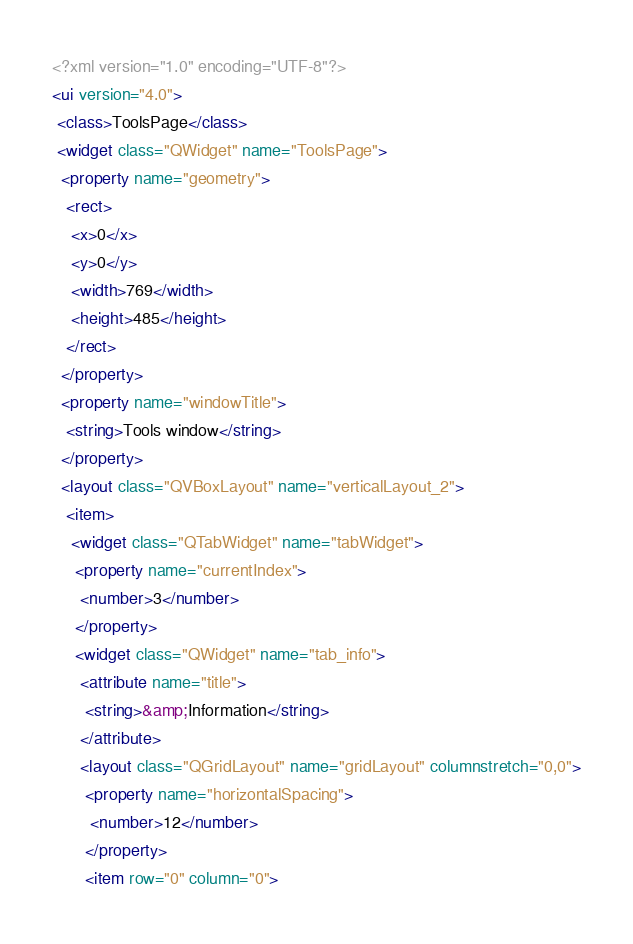<code> <loc_0><loc_0><loc_500><loc_500><_XML_><?xml version="1.0" encoding="UTF-8"?>
<ui version="4.0">
 <class>ToolsPage</class>
 <widget class="QWidget" name="ToolsPage">
  <property name="geometry">
   <rect>
    <x>0</x>
    <y>0</y>
    <width>769</width>
    <height>485</height>
   </rect>
  </property>
  <property name="windowTitle">
   <string>Tools window</string>
  </property>
  <layout class="QVBoxLayout" name="verticalLayout_2">
   <item>
    <widget class="QTabWidget" name="tabWidget">
     <property name="currentIndex">
      <number>3</number>
     </property>
     <widget class="QWidget" name="tab_info">
      <attribute name="title">
       <string>&amp;Information</string>
      </attribute>
      <layout class="QGridLayout" name="gridLayout" columnstretch="0,0">
       <property name="horizontalSpacing">
        <number>12</number>
       </property>
       <item row="0" column="0"></code> 